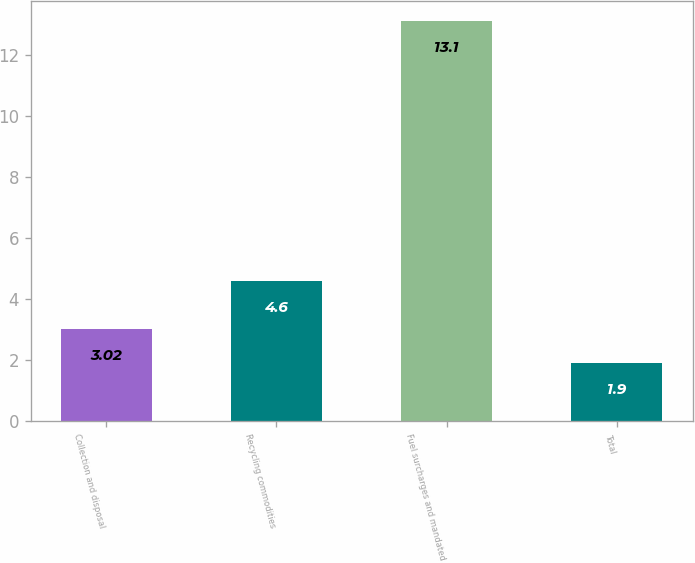Convert chart to OTSL. <chart><loc_0><loc_0><loc_500><loc_500><bar_chart><fcel>Collection and disposal<fcel>Recycling commodities<fcel>Fuel surcharges and mandated<fcel>Total<nl><fcel>3.02<fcel>4.6<fcel>13.1<fcel>1.9<nl></chart> 